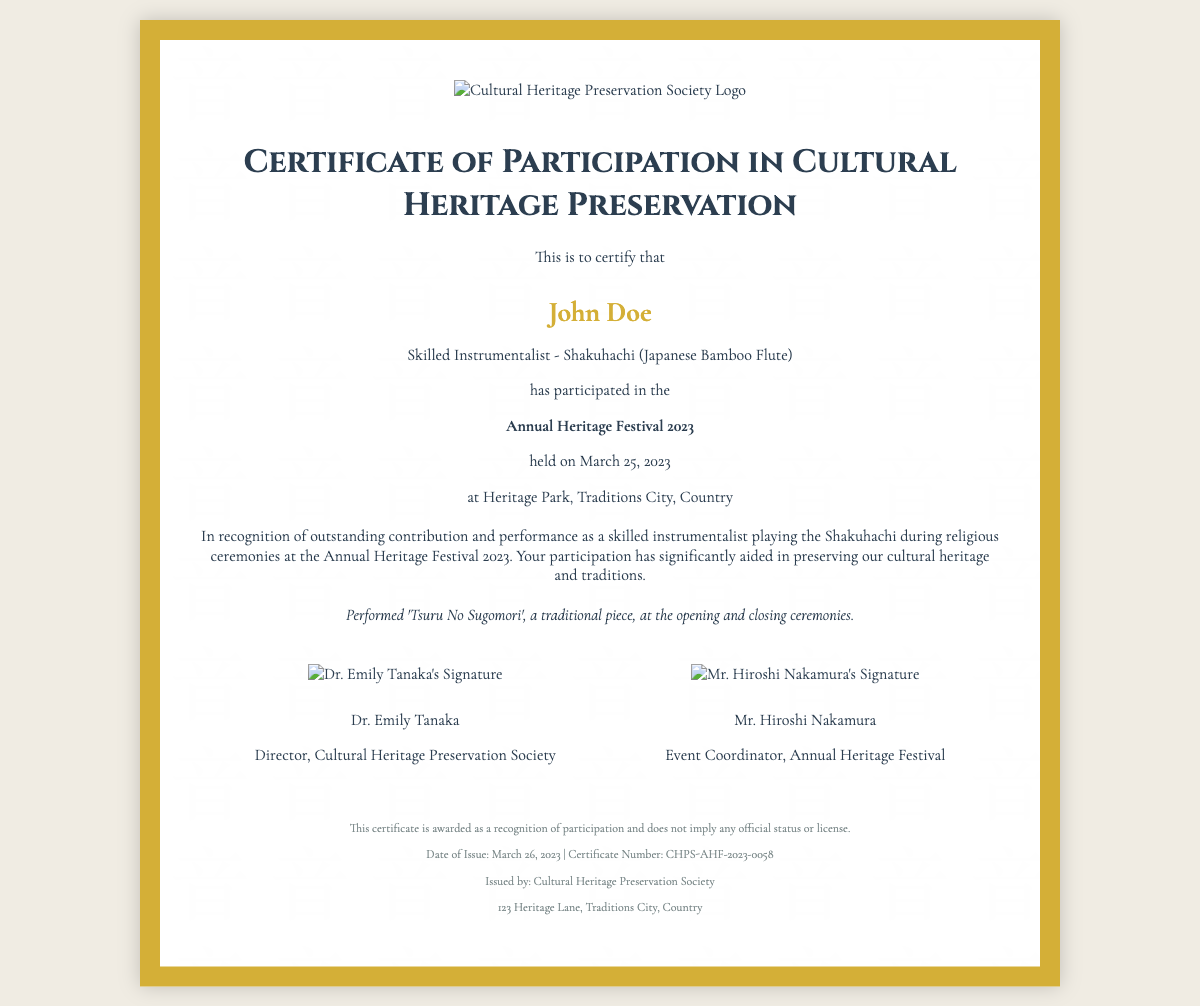What is the name of the participant? The name of the participant is prominently stated in the certificate.
Answer: John Doe What instrument did the participant play? The certificate specifies the traditional instrument the participant played.
Answer: Shakuhachi What event is this certificate for? The event for which the certificate is awarded is clearly mentioned.
Answer: Annual Heritage Festival 2023 When was the festival held? The date of the festival is provided on the certificate.
Answer: March 25, 2023 Who issued the certificate? The issuer of the certificate is noted at the bottom of the document.
Answer: Cultural Heritage Preservation Society What specific performance is mentioned in the participation details? The certificate highlights a specific piece performed by the participant.
Answer: Tsuru No Sugomori What is the certificate number? A unique identifier for the certificate is indicated on the document.
Answer: CHPS-AHF-2023-0058 Who is the director of the Cultural Heritage Preservation Society? The name and title of the director are listed on the certificate.
Answer: Dr. Emily Tanaka What does the footer say about the certificate status? The footer provides important information regarding the status of the certificate.
Answer: Recognition of participation and does not imply any official status or license 